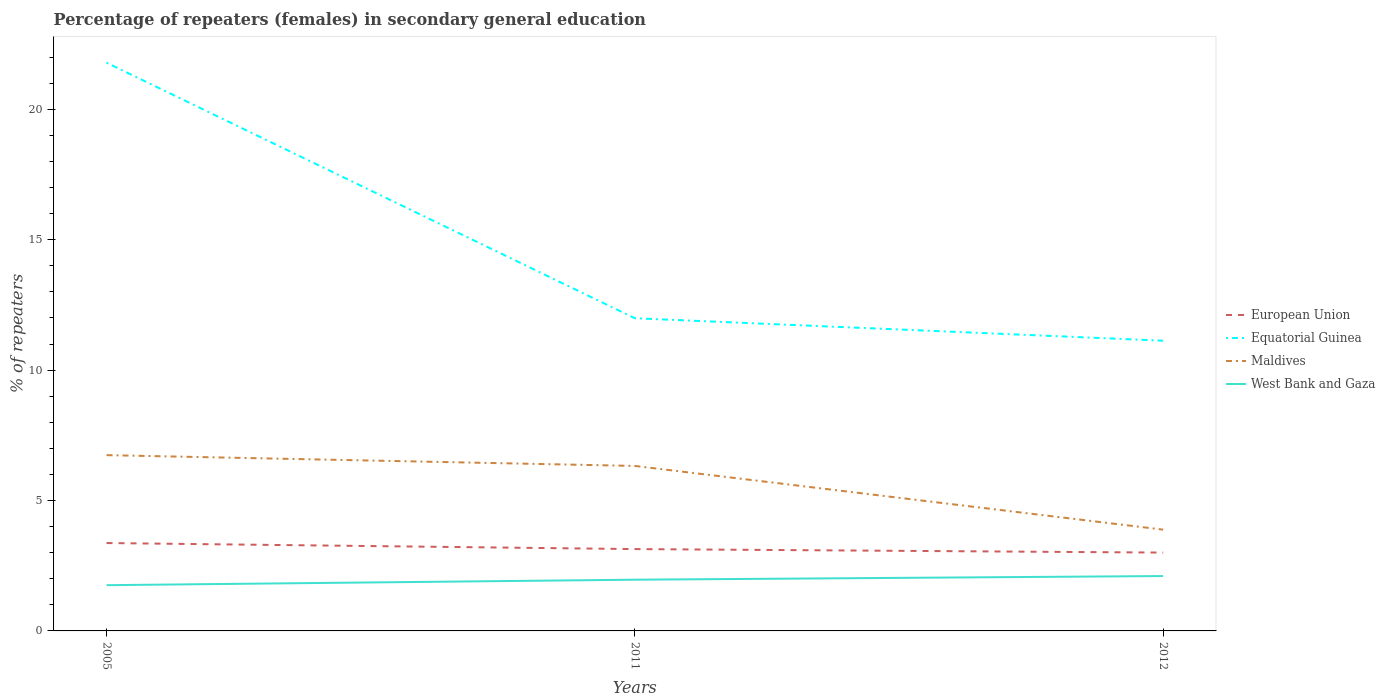How many different coloured lines are there?
Make the answer very short. 4. Across all years, what is the maximum percentage of female repeaters in Maldives?
Offer a very short reply. 3.88. What is the total percentage of female repeaters in West Bank and Gaza in the graph?
Your answer should be very brief. -0.21. What is the difference between the highest and the second highest percentage of female repeaters in European Union?
Keep it short and to the point. 0.37. What is the difference between the highest and the lowest percentage of female repeaters in West Bank and Gaza?
Your answer should be compact. 2. Is the percentage of female repeaters in Equatorial Guinea strictly greater than the percentage of female repeaters in European Union over the years?
Offer a very short reply. No. How many lines are there?
Offer a terse response. 4. What is the difference between two consecutive major ticks on the Y-axis?
Give a very brief answer. 5. Does the graph contain any zero values?
Provide a succinct answer. No. How many legend labels are there?
Provide a short and direct response. 4. What is the title of the graph?
Keep it short and to the point. Percentage of repeaters (females) in secondary general education. What is the label or title of the Y-axis?
Make the answer very short. % of repeaters. What is the % of repeaters in European Union in 2005?
Offer a terse response. 3.37. What is the % of repeaters of Equatorial Guinea in 2005?
Your response must be concise. 21.79. What is the % of repeaters in Maldives in 2005?
Offer a very short reply. 6.74. What is the % of repeaters of West Bank and Gaza in 2005?
Offer a very short reply. 1.75. What is the % of repeaters in European Union in 2011?
Offer a terse response. 3.14. What is the % of repeaters in Equatorial Guinea in 2011?
Your response must be concise. 11.99. What is the % of repeaters in Maldives in 2011?
Make the answer very short. 6.33. What is the % of repeaters of West Bank and Gaza in 2011?
Offer a very short reply. 1.96. What is the % of repeaters in European Union in 2012?
Make the answer very short. 3. What is the % of repeaters in Equatorial Guinea in 2012?
Your answer should be compact. 11.13. What is the % of repeaters of Maldives in 2012?
Provide a succinct answer. 3.88. What is the % of repeaters of West Bank and Gaza in 2012?
Your answer should be compact. 2.1. Across all years, what is the maximum % of repeaters of European Union?
Your answer should be very brief. 3.37. Across all years, what is the maximum % of repeaters in Equatorial Guinea?
Make the answer very short. 21.79. Across all years, what is the maximum % of repeaters of Maldives?
Ensure brevity in your answer.  6.74. Across all years, what is the maximum % of repeaters in West Bank and Gaza?
Your answer should be compact. 2.1. Across all years, what is the minimum % of repeaters in European Union?
Your answer should be very brief. 3. Across all years, what is the minimum % of repeaters of Equatorial Guinea?
Your answer should be very brief. 11.13. Across all years, what is the minimum % of repeaters in Maldives?
Offer a terse response. 3.88. Across all years, what is the minimum % of repeaters of West Bank and Gaza?
Keep it short and to the point. 1.75. What is the total % of repeaters in European Union in the graph?
Offer a terse response. 9.51. What is the total % of repeaters in Equatorial Guinea in the graph?
Your answer should be very brief. 44.91. What is the total % of repeaters in Maldives in the graph?
Your answer should be very brief. 16.95. What is the total % of repeaters of West Bank and Gaza in the graph?
Your answer should be compact. 5.82. What is the difference between the % of repeaters of European Union in 2005 and that in 2011?
Provide a succinct answer. 0.23. What is the difference between the % of repeaters in Equatorial Guinea in 2005 and that in 2011?
Offer a very short reply. 9.8. What is the difference between the % of repeaters of Maldives in 2005 and that in 2011?
Your answer should be very brief. 0.41. What is the difference between the % of repeaters of West Bank and Gaza in 2005 and that in 2011?
Provide a short and direct response. -0.21. What is the difference between the % of repeaters of European Union in 2005 and that in 2012?
Give a very brief answer. 0.37. What is the difference between the % of repeaters of Equatorial Guinea in 2005 and that in 2012?
Give a very brief answer. 10.66. What is the difference between the % of repeaters of Maldives in 2005 and that in 2012?
Your answer should be very brief. 2.86. What is the difference between the % of repeaters in West Bank and Gaza in 2005 and that in 2012?
Your response must be concise. -0.35. What is the difference between the % of repeaters of European Union in 2011 and that in 2012?
Provide a succinct answer. 0.13. What is the difference between the % of repeaters in Equatorial Guinea in 2011 and that in 2012?
Your response must be concise. 0.86. What is the difference between the % of repeaters in Maldives in 2011 and that in 2012?
Make the answer very short. 2.44. What is the difference between the % of repeaters of West Bank and Gaza in 2011 and that in 2012?
Your answer should be compact. -0.14. What is the difference between the % of repeaters in European Union in 2005 and the % of repeaters in Equatorial Guinea in 2011?
Your answer should be compact. -8.62. What is the difference between the % of repeaters in European Union in 2005 and the % of repeaters in Maldives in 2011?
Your answer should be compact. -2.96. What is the difference between the % of repeaters in European Union in 2005 and the % of repeaters in West Bank and Gaza in 2011?
Keep it short and to the point. 1.41. What is the difference between the % of repeaters of Equatorial Guinea in 2005 and the % of repeaters of Maldives in 2011?
Provide a succinct answer. 15.46. What is the difference between the % of repeaters of Equatorial Guinea in 2005 and the % of repeaters of West Bank and Gaza in 2011?
Offer a very short reply. 19.83. What is the difference between the % of repeaters in Maldives in 2005 and the % of repeaters in West Bank and Gaza in 2011?
Provide a succinct answer. 4.78. What is the difference between the % of repeaters in European Union in 2005 and the % of repeaters in Equatorial Guinea in 2012?
Offer a very short reply. -7.76. What is the difference between the % of repeaters of European Union in 2005 and the % of repeaters of Maldives in 2012?
Ensure brevity in your answer.  -0.51. What is the difference between the % of repeaters of European Union in 2005 and the % of repeaters of West Bank and Gaza in 2012?
Your response must be concise. 1.27. What is the difference between the % of repeaters of Equatorial Guinea in 2005 and the % of repeaters of Maldives in 2012?
Ensure brevity in your answer.  17.91. What is the difference between the % of repeaters of Equatorial Guinea in 2005 and the % of repeaters of West Bank and Gaza in 2012?
Your answer should be very brief. 19.69. What is the difference between the % of repeaters of Maldives in 2005 and the % of repeaters of West Bank and Gaza in 2012?
Provide a succinct answer. 4.64. What is the difference between the % of repeaters in European Union in 2011 and the % of repeaters in Equatorial Guinea in 2012?
Give a very brief answer. -7.99. What is the difference between the % of repeaters in European Union in 2011 and the % of repeaters in Maldives in 2012?
Provide a short and direct response. -0.74. What is the difference between the % of repeaters of European Union in 2011 and the % of repeaters of West Bank and Gaza in 2012?
Keep it short and to the point. 1.03. What is the difference between the % of repeaters in Equatorial Guinea in 2011 and the % of repeaters in Maldives in 2012?
Make the answer very short. 8.11. What is the difference between the % of repeaters of Equatorial Guinea in 2011 and the % of repeaters of West Bank and Gaza in 2012?
Ensure brevity in your answer.  9.89. What is the difference between the % of repeaters of Maldives in 2011 and the % of repeaters of West Bank and Gaza in 2012?
Your answer should be very brief. 4.22. What is the average % of repeaters in European Union per year?
Your answer should be compact. 3.17. What is the average % of repeaters in Equatorial Guinea per year?
Give a very brief answer. 14.97. What is the average % of repeaters in Maldives per year?
Give a very brief answer. 5.65. What is the average % of repeaters in West Bank and Gaza per year?
Give a very brief answer. 1.94. In the year 2005, what is the difference between the % of repeaters of European Union and % of repeaters of Equatorial Guinea?
Offer a very short reply. -18.42. In the year 2005, what is the difference between the % of repeaters of European Union and % of repeaters of Maldives?
Provide a short and direct response. -3.37. In the year 2005, what is the difference between the % of repeaters in European Union and % of repeaters in West Bank and Gaza?
Offer a very short reply. 1.62. In the year 2005, what is the difference between the % of repeaters of Equatorial Guinea and % of repeaters of Maldives?
Your answer should be very brief. 15.05. In the year 2005, what is the difference between the % of repeaters of Equatorial Guinea and % of repeaters of West Bank and Gaza?
Make the answer very short. 20.04. In the year 2005, what is the difference between the % of repeaters in Maldives and % of repeaters in West Bank and Gaza?
Ensure brevity in your answer.  4.99. In the year 2011, what is the difference between the % of repeaters of European Union and % of repeaters of Equatorial Guinea?
Provide a succinct answer. -8.85. In the year 2011, what is the difference between the % of repeaters of European Union and % of repeaters of Maldives?
Your response must be concise. -3.19. In the year 2011, what is the difference between the % of repeaters in European Union and % of repeaters in West Bank and Gaza?
Ensure brevity in your answer.  1.17. In the year 2011, what is the difference between the % of repeaters of Equatorial Guinea and % of repeaters of Maldives?
Your answer should be compact. 5.66. In the year 2011, what is the difference between the % of repeaters of Equatorial Guinea and % of repeaters of West Bank and Gaza?
Provide a short and direct response. 10.03. In the year 2011, what is the difference between the % of repeaters in Maldives and % of repeaters in West Bank and Gaza?
Your answer should be compact. 4.36. In the year 2012, what is the difference between the % of repeaters in European Union and % of repeaters in Equatorial Guinea?
Give a very brief answer. -8.12. In the year 2012, what is the difference between the % of repeaters of European Union and % of repeaters of Maldives?
Ensure brevity in your answer.  -0.88. In the year 2012, what is the difference between the % of repeaters in European Union and % of repeaters in West Bank and Gaza?
Ensure brevity in your answer.  0.9. In the year 2012, what is the difference between the % of repeaters of Equatorial Guinea and % of repeaters of Maldives?
Keep it short and to the point. 7.25. In the year 2012, what is the difference between the % of repeaters in Equatorial Guinea and % of repeaters in West Bank and Gaza?
Ensure brevity in your answer.  9.02. In the year 2012, what is the difference between the % of repeaters in Maldives and % of repeaters in West Bank and Gaza?
Keep it short and to the point. 1.78. What is the ratio of the % of repeaters of European Union in 2005 to that in 2011?
Give a very brief answer. 1.07. What is the ratio of the % of repeaters of Equatorial Guinea in 2005 to that in 2011?
Your answer should be compact. 1.82. What is the ratio of the % of repeaters in Maldives in 2005 to that in 2011?
Your answer should be very brief. 1.07. What is the ratio of the % of repeaters of West Bank and Gaza in 2005 to that in 2011?
Keep it short and to the point. 0.89. What is the ratio of the % of repeaters of European Union in 2005 to that in 2012?
Provide a short and direct response. 1.12. What is the ratio of the % of repeaters in Equatorial Guinea in 2005 to that in 2012?
Offer a terse response. 1.96. What is the ratio of the % of repeaters in Maldives in 2005 to that in 2012?
Ensure brevity in your answer.  1.74. What is the ratio of the % of repeaters of West Bank and Gaza in 2005 to that in 2012?
Your response must be concise. 0.83. What is the ratio of the % of repeaters of European Union in 2011 to that in 2012?
Your answer should be very brief. 1.04. What is the ratio of the % of repeaters of Equatorial Guinea in 2011 to that in 2012?
Your response must be concise. 1.08. What is the ratio of the % of repeaters in Maldives in 2011 to that in 2012?
Your answer should be compact. 1.63. What is the ratio of the % of repeaters of West Bank and Gaza in 2011 to that in 2012?
Your response must be concise. 0.93. What is the difference between the highest and the second highest % of repeaters of European Union?
Provide a short and direct response. 0.23. What is the difference between the highest and the second highest % of repeaters in Equatorial Guinea?
Offer a terse response. 9.8. What is the difference between the highest and the second highest % of repeaters of Maldives?
Offer a terse response. 0.41. What is the difference between the highest and the second highest % of repeaters in West Bank and Gaza?
Provide a short and direct response. 0.14. What is the difference between the highest and the lowest % of repeaters of European Union?
Your answer should be compact. 0.37. What is the difference between the highest and the lowest % of repeaters in Equatorial Guinea?
Your answer should be compact. 10.66. What is the difference between the highest and the lowest % of repeaters in Maldives?
Offer a very short reply. 2.86. What is the difference between the highest and the lowest % of repeaters of West Bank and Gaza?
Make the answer very short. 0.35. 